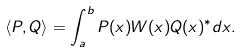Convert formula to latex. <formula><loc_0><loc_0><loc_500><loc_500>\langle P , Q \rangle = \int _ { a } ^ { b } P ( x ) W ( x ) Q ( x ) ^ { * } d x .</formula> 